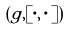<formula> <loc_0><loc_0><loc_500><loc_500>( g , [ \cdot , \cdot ] )</formula> 